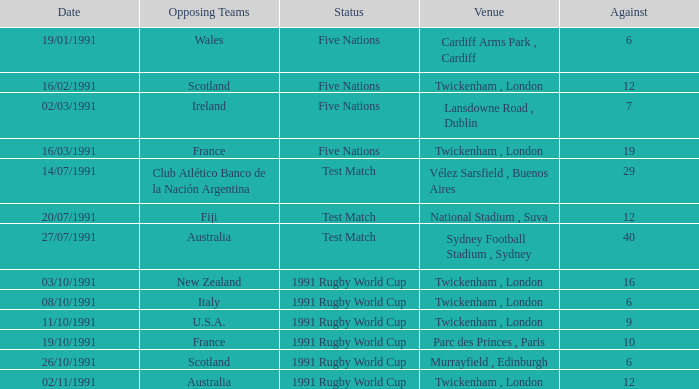What is Against, when Opposing Teams is "Australia", and when Date is "27/07/1991"? 40.0. 